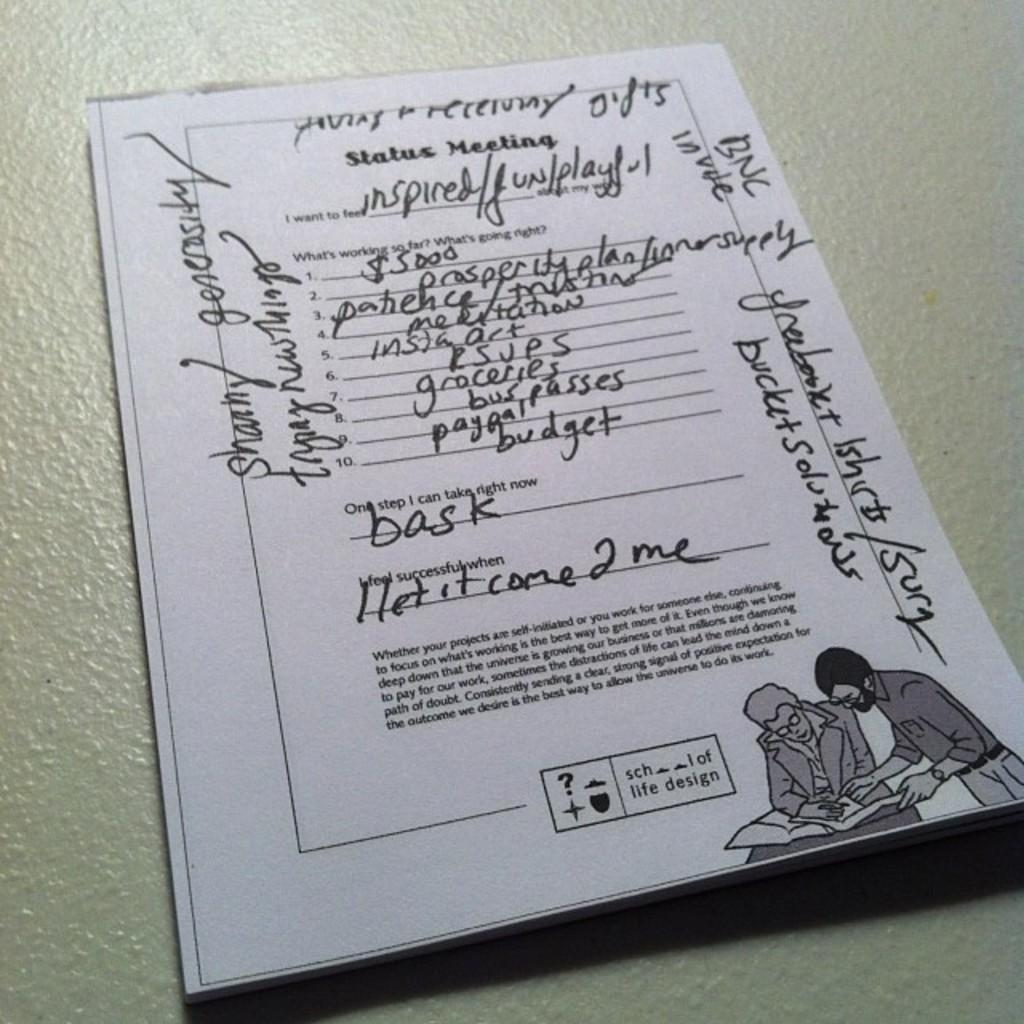What object is placed on a surface in the image? There is a book placed on a surface in the image. Can you describe the book's position or orientation in the image? The provided facts do not specify the book's position or orientation. What might someone be about to do with the book in the image? It is not possible to determine what someone might be about to do with the book from the given facts. What type of instrument is the book playing in the image? There is no instrument present in the image, and the book is not playing any music. 